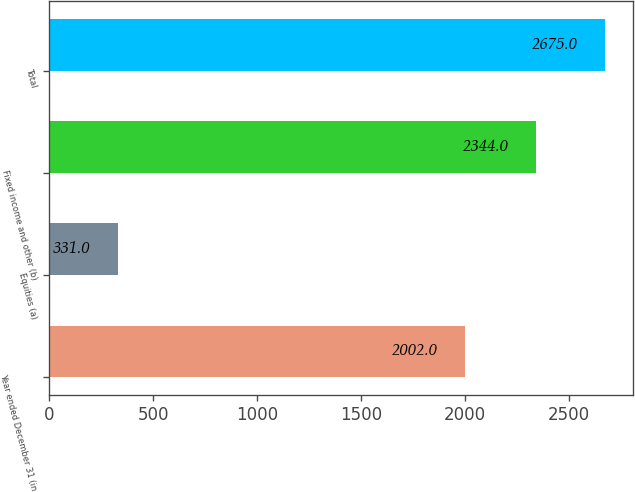<chart> <loc_0><loc_0><loc_500><loc_500><bar_chart><fcel>Year ended December 31 (in<fcel>Equities (a)<fcel>Fixed income and other (b)<fcel>Total<nl><fcel>2002<fcel>331<fcel>2344<fcel>2675<nl></chart> 